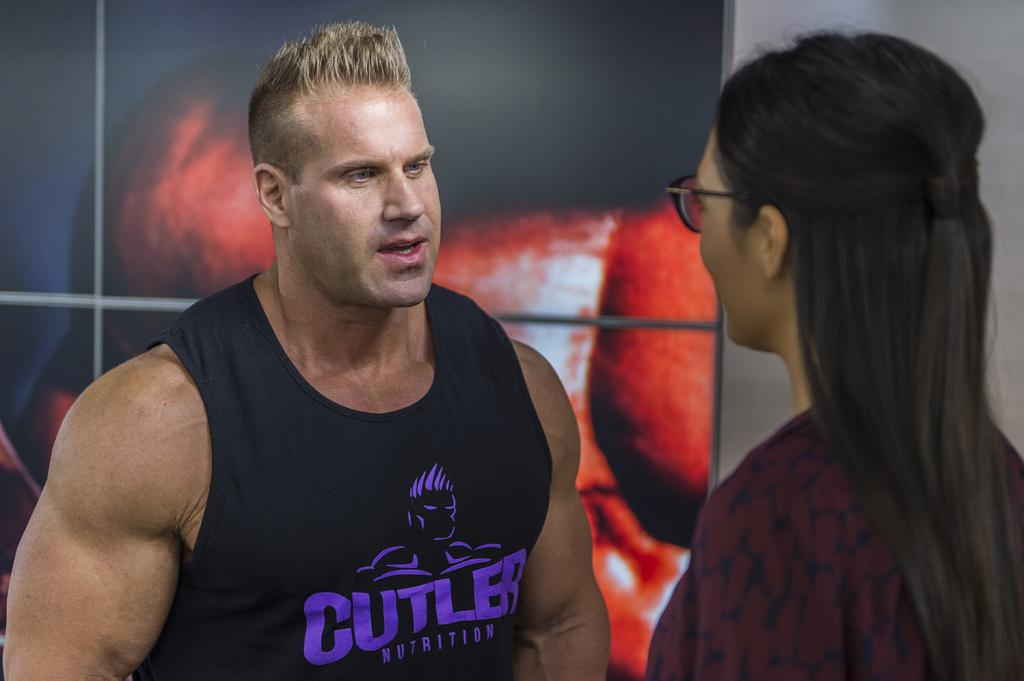Provide a one-sentence caption for the provided image. A man with blonde hair and a tank that says cutler on it talking to a woman with long dark hair and glasses. 